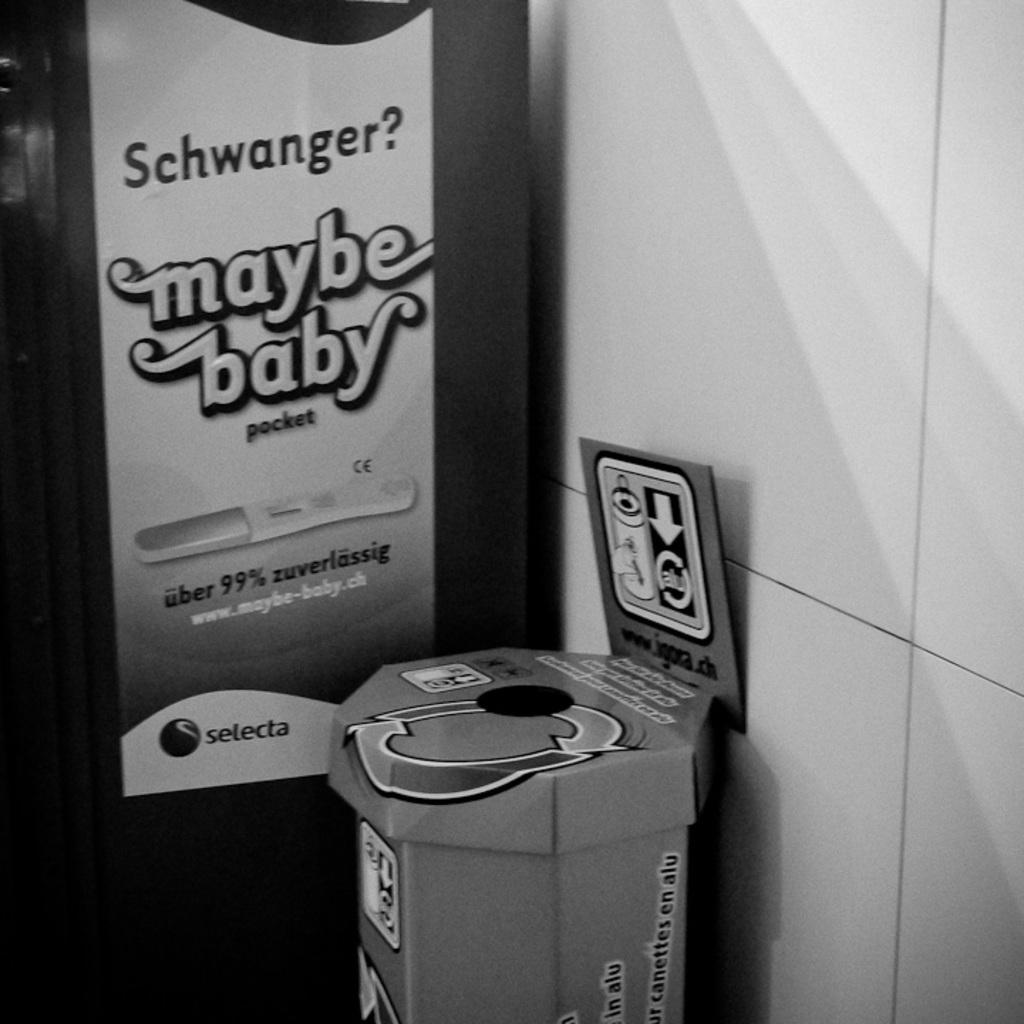<image>
Relay a brief, clear account of the picture shown. A black and white picture with a sign including the words maybe baby. 